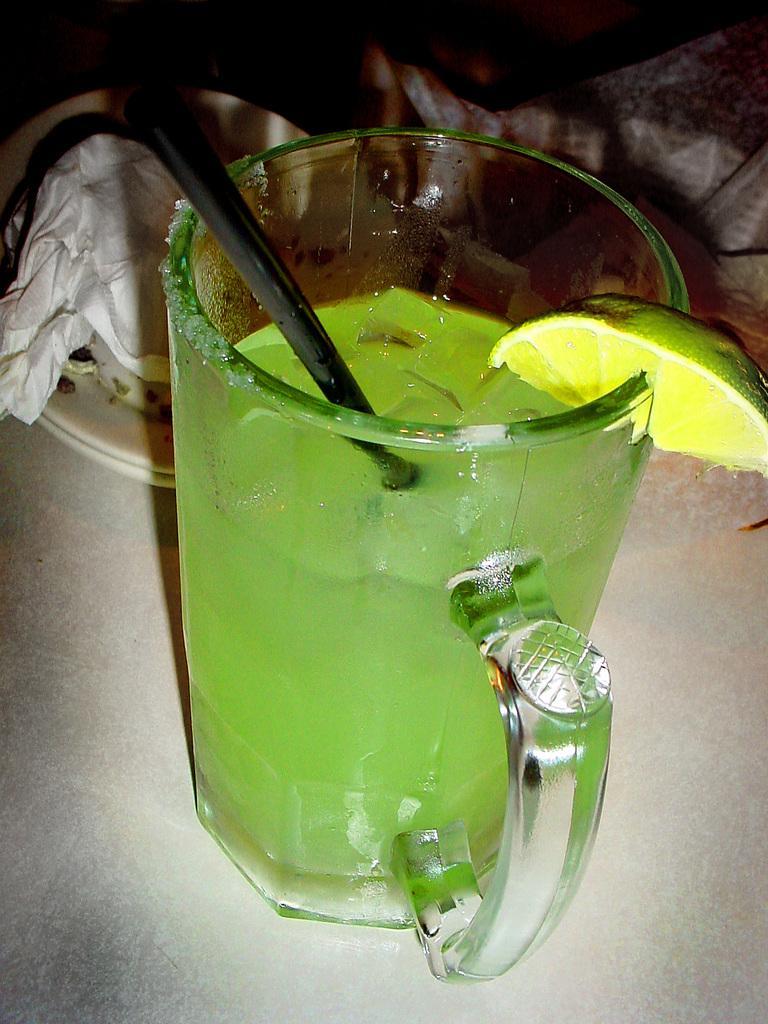How would you summarize this image in a sentence or two? In this picture we can see a lemon, glass with a straw, drink in it and this glass is on the surface and in the background we can see plates, tissue paper and some objects. 